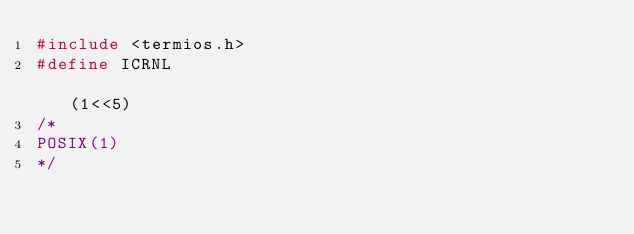<code> <loc_0><loc_0><loc_500><loc_500><_C_>#include <termios.h>
#define ICRNL                                                             (1<<5)
/*
POSIX(1)
*/
</code> 